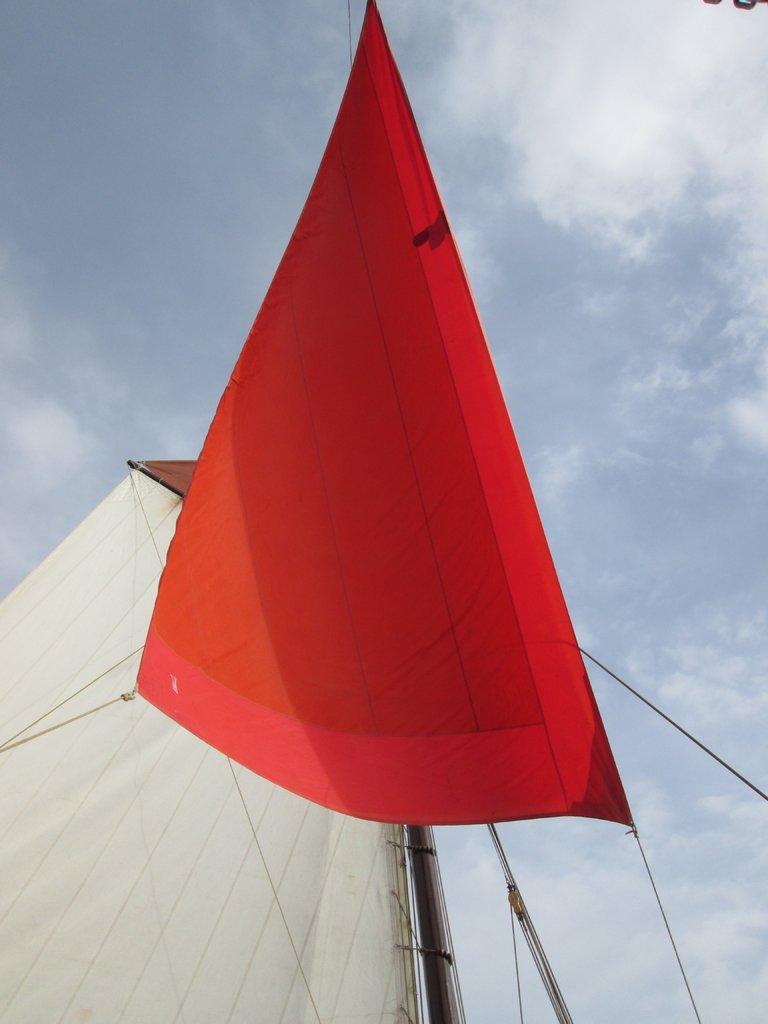Describe this image in one or two sentences. There is a red color mast, which is attached to the threads and a white color mast which is attached to the pole. In the background, there are clouds in the sky. 